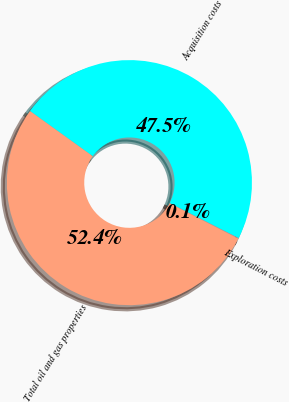Convert chart. <chart><loc_0><loc_0><loc_500><loc_500><pie_chart><fcel>Acquisition costs<fcel>Exploration costs<fcel>Total oil and gas properties<nl><fcel>47.55%<fcel>0.07%<fcel>52.38%<nl></chart> 